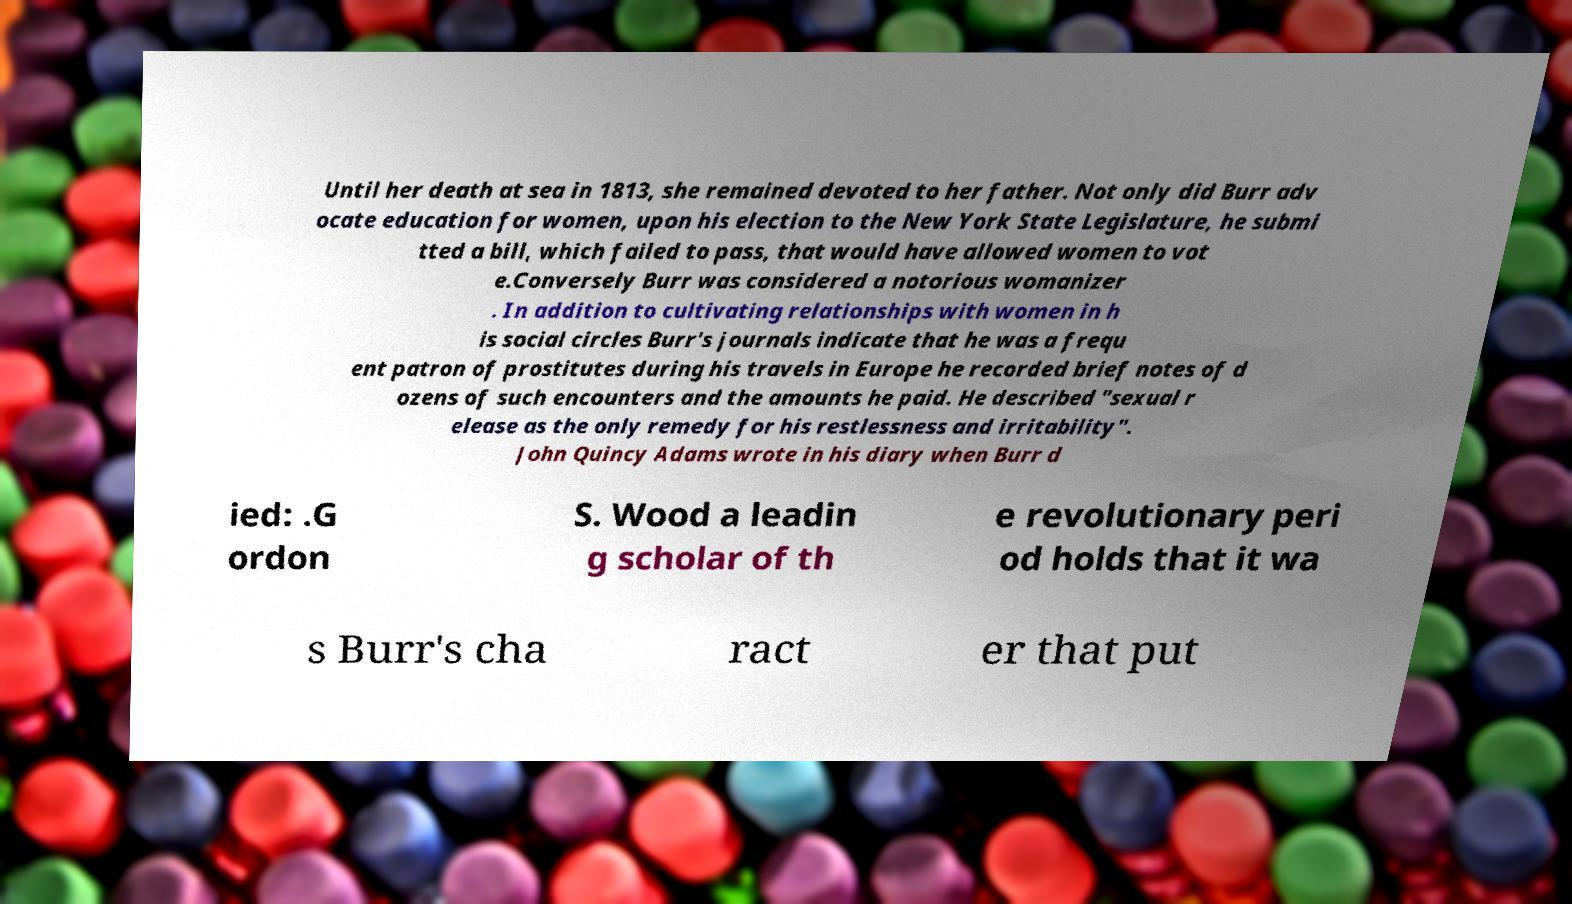Could you extract and type out the text from this image? Until her death at sea in 1813, she remained devoted to her father. Not only did Burr adv ocate education for women, upon his election to the New York State Legislature, he submi tted a bill, which failed to pass, that would have allowed women to vot e.Conversely Burr was considered a notorious womanizer . In addition to cultivating relationships with women in h is social circles Burr's journals indicate that he was a frequ ent patron of prostitutes during his travels in Europe he recorded brief notes of d ozens of such encounters and the amounts he paid. He described "sexual r elease as the only remedy for his restlessness and irritability". John Quincy Adams wrote in his diary when Burr d ied: .G ordon S. Wood a leadin g scholar of th e revolutionary peri od holds that it wa s Burr's cha ract er that put 